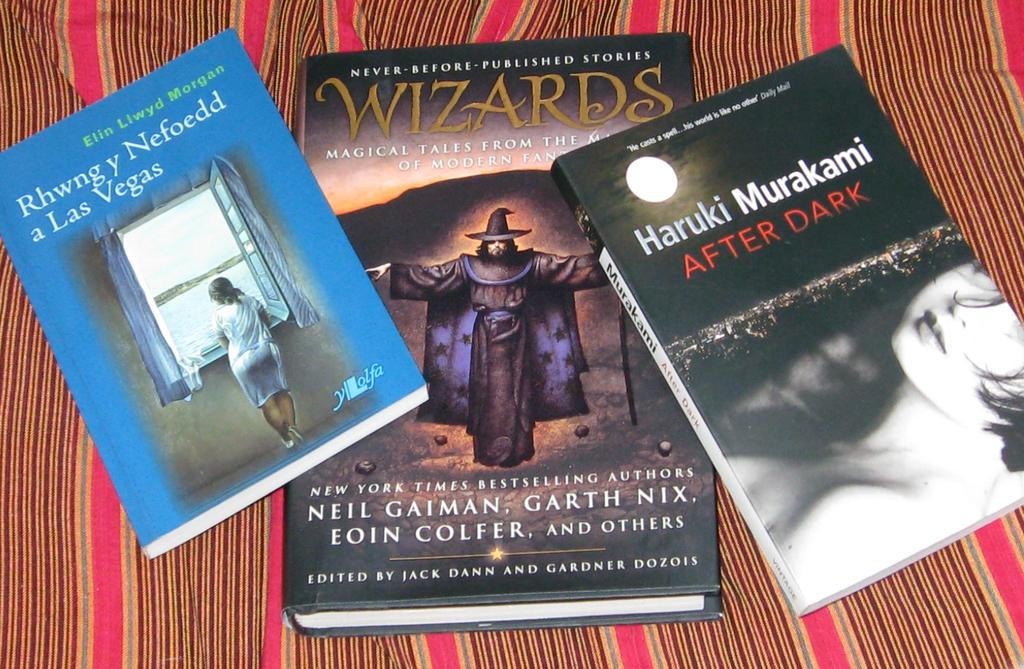<image>
Relay a brief, clear account of the picture shown. Three books lying on a bed sheet, the book on the right is After Dark, by Haruki Murakami. 